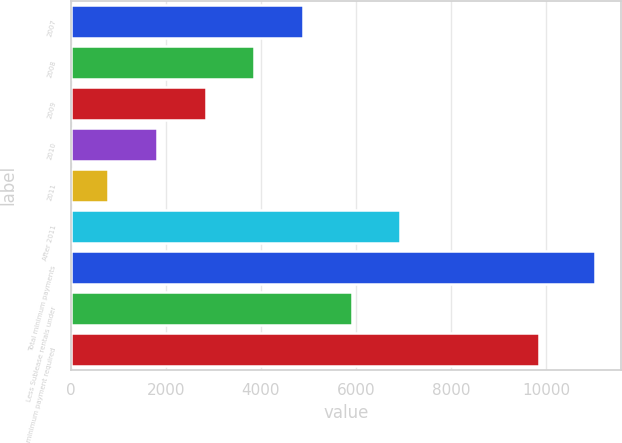<chart> <loc_0><loc_0><loc_500><loc_500><bar_chart><fcel>2007<fcel>2008<fcel>2009<fcel>2010<fcel>2011<fcel>After 2011<fcel>Total minimum payments<fcel>Less Sublease rentals under<fcel>Net minimum payment required<nl><fcel>4886.2<fcel>3862.4<fcel>2838.6<fcel>1814.8<fcel>791<fcel>6933.8<fcel>11029<fcel>5910<fcel>9852<nl></chart> 